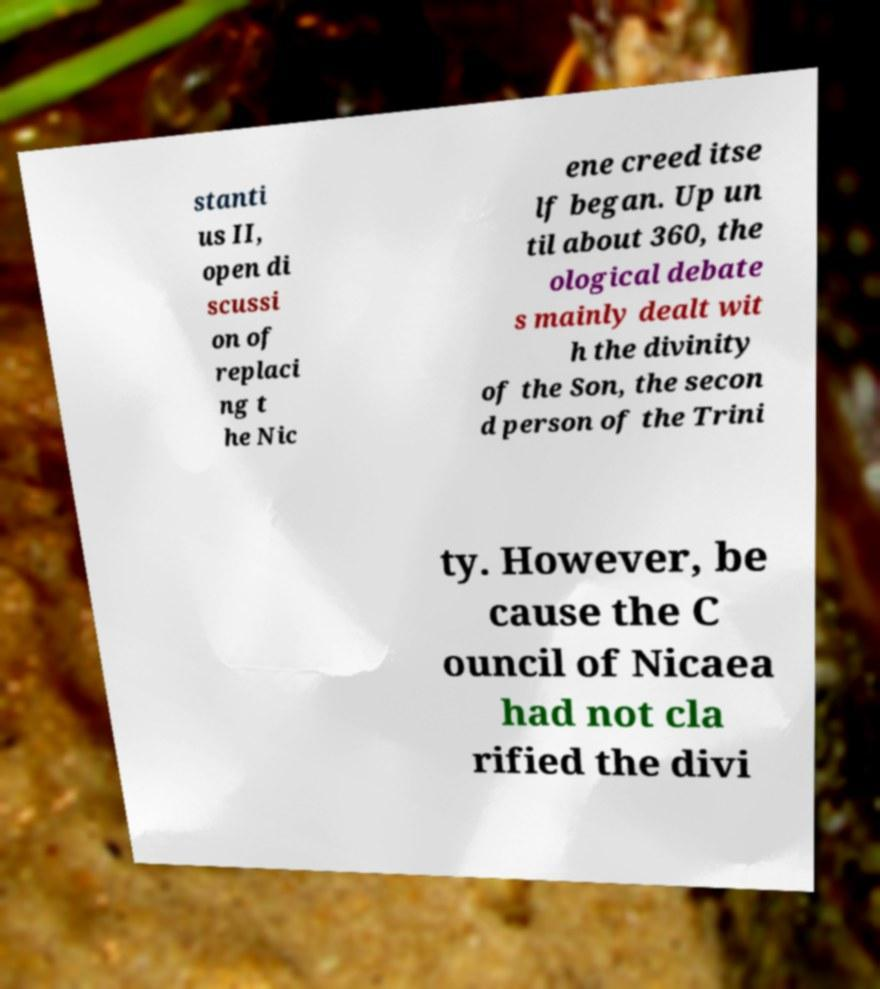Could you assist in decoding the text presented in this image and type it out clearly? stanti us II, open di scussi on of replaci ng t he Nic ene creed itse lf began. Up un til about 360, the ological debate s mainly dealt wit h the divinity of the Son, the secon d person of the Trini ty. However, be cause the C ouncil of Nicaea had not cla rified the divi 